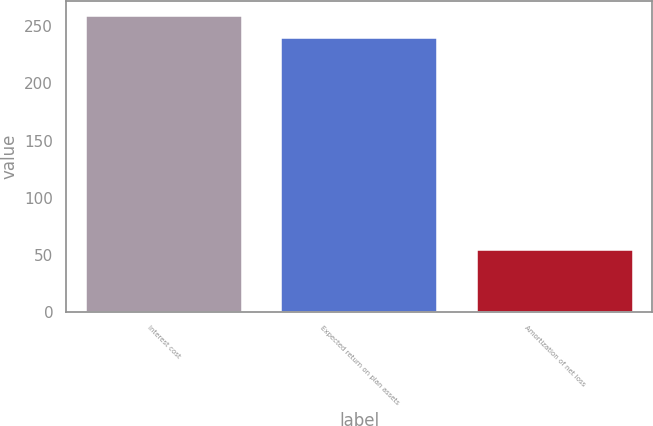<chart> <loc_0><loc_0><loc_500><loc_500><bar_chart><fcel>Interest cost<fcel>Expected return on plan assets<fcel>Amortization of net loss<nl><fcel>259.5<fcel>240<fcel>54<nl></chart> 